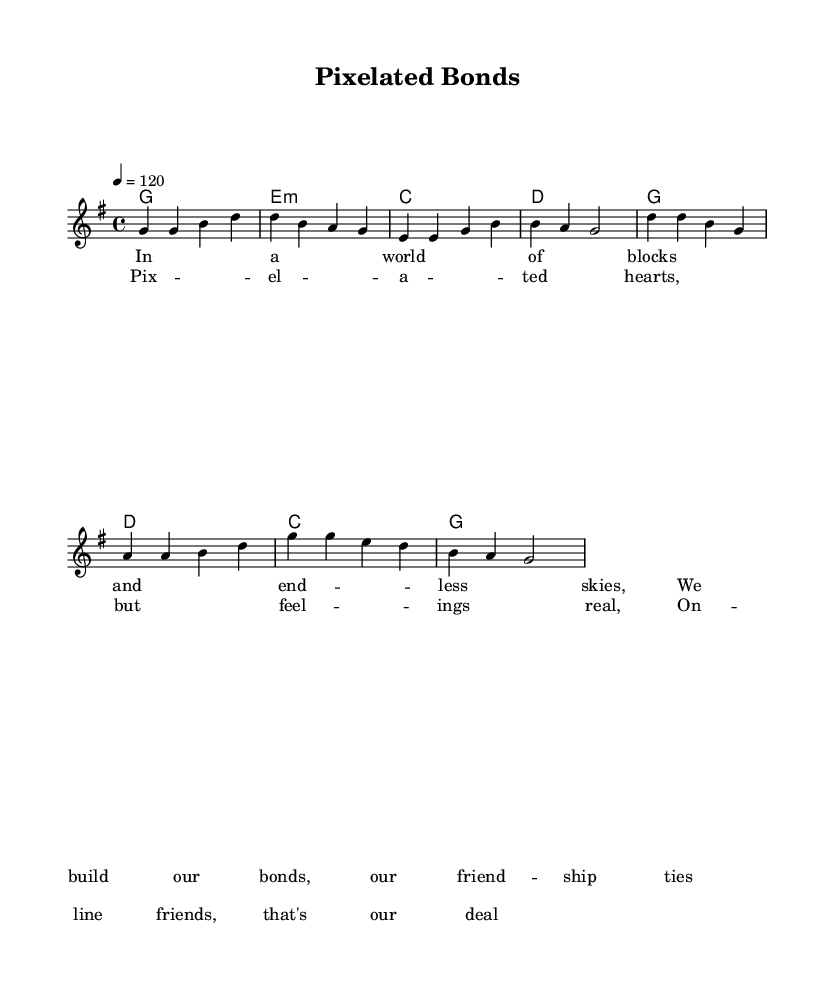What is the key signature of this music? The key signature is G major, which has one sharp (F#). The presence of one sharp in the key signature indicates it is in the key of G major.
Answer: G major What is the time signature of this music? The time signature is 4/4, indicated at the beginning of the score. This means there are four beats in each measure, and the quarter note receives one beat.
Answer: 4/4 What is the tempo marking of this piece? The tempo marking is indicated as 4 = 120, which means the quarter note is played at a steady speed of 120 beats per minute. This is a moderate to fast tempo suitable for upbeat music.
Answer: 120 How many measures are in the verses? Counting the measures in the verse section, we see there are four measures in total. Each line of the verse corresponds to four beats, so it comprises four measures.
Answer: 4 What is the chord progression for the verse? The chord progression for the verse follows: G, Em, C, D. We can see this from the chord symbols written above the melody in that section.
Answer: G, Em, C, D Which unique theme does this song celebrate? The song celebrates online friendships and community, as indicated by the lyrics discussing building bonds and the feelings of online connections. This theme is common in Country Rock music.
Answer: Online friendships 